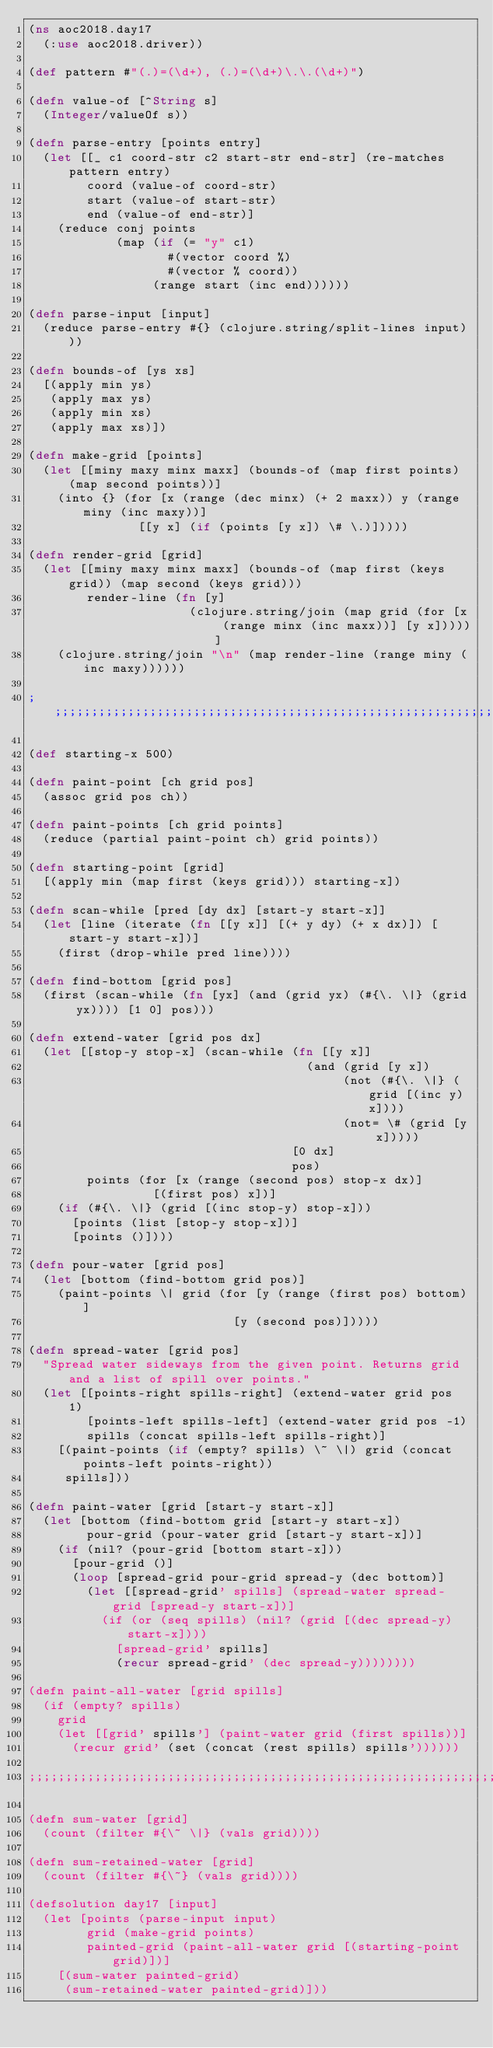Convert code to text. <code><loc_0><loc_0><loc_500><loc_500><_Clojure_>(ns aoc2018.day17
  (:use aoc2018.driver))

(def pattern #"(.)=(\d+), (.)=(\d+)\.\.(\d+)")

(defn value-of [^String s]
  (Integer/valueOf s))

(defn parse-entry [points entry]
  (let [[_ c1 coord-str c2 start-str end-str] (re-matches pattern entry)
        coord (value-of coord-str)
        start (value-of start-str)
        end (value-of end-str)]
    (reduce conj points
            (map (if (= "y" c1)
                   #(vector coord %)
                   #(vector % coord))
                 (range start (inc end))))))

(defn parse-input [input]
  (reduce parse-entry #{} (clojure.string/split-lines input)))

(defn bounds-of [ys xs]
  [(apply min ys)
   (apply max ys)
   (apply min xs)
   (apply max xs)])

(defn make-grid [points]
  (let [[miny maxy minx maxx] (bounds-of (map first points) (map second points))]
    (into {} (for [x (range (dec minx) (+ 2 maxx)) y (range miny (inc maxy))]
               [[y x] (if (points [y x]) \# \.)]))))

(defn render-grid [grid]
  (let [[miny maxy minx maxx] (bounds-of (map first (keys grid)) (map second (keys grid)))
        render-line (fn [y]
                      (clojure.string/join (map grid (for [x (range minx (inc maxx))] [y x]))))]
    (clojure.string/join "\n" (map render-line (range miny (inc maxy))))))

;;;;;;;;;;;;;;;;;;;;;;;;;;;;;;;;;;;;;;;;;;;;;;;;;;;;;;;;;;;;;;;;

(def starting-x 500)

(defn paint-point [ch grid pos]
  (assoc grid pos ch))

(defn paint-points [ch grid points]
  (reduce (partial paint-point ch) grid points))

(defn starting-point [grid]
  [(apply min (map first (keys grid))) starting-x])

(defn scan-while [pred [dy dx] [start-y start-x]]
  (let [line (iterate (fn [[y x]] [(+ y dy) (+ x dx)]) [start-y start-x])]
    (first (drop-while pred line))))

(defn find-bottom [grid pos]
  (first (scan-while (fn [yx] (and (grid yx) (#{\. \|} (grid yx)))) [1 0] pos)))

(defn extend-water [grid pos dx]
  (let [[stop-y stop-x] (scan-while (fn [[y x]]
                                      (and (grid [y x])
                                           (not (#{\. \|} (grid [(inc y) x])))
                                           (not= \# (grid [y x]))))
                                    [0 dx]
                                    pos)
        points (for [x (range (second pos) stop-x dx)]
                 [(first pos) x])]
    (if (#{\. \|} (grid [(inc stop-y) stop-x]))
      [points (list [stop-y stop-x])]
      [points ()])))

(defn pour-water [grid pos]
  (let [bottom (find-bottom grid pos)]
    (paint-points \| grid (for [y (range (first pos) bottom)]
                            [y (second pos)]))))

(defn spread-water [grid pos]
  "Spread water sideways from the given point. Returns grid and a list of spill over points."
  (let [[points-right spills-right] (extend-water grid pos 1)
        [points-left spills-left] (extend-water grid pos -1)
        spills (concat spills-left spills-right)]
    [(paint-points (if (empty? spills) \~ \|) grid (concat points-left points-right))
     spills]))

(defn paint-water [grid [start-y start-x]]
  (let [bottom (find-bottom grid [start-y start-x])
        pour-grid (pour-water grid [start-y start-x])]
    (if (nil? (pour-grid [bottom start-x]))
      [pour-grid ()]
      (loop [spread-grid pour-grid spread-y (dec bottom)]
        (let [[spread-grid' spills] (spread-water spread-grid [spread-y start-x])]
          (if (or (seq spills) (nil? (grid [(dec spread-y) start-x])))
            [spread-grid' spills]
            (recur spread-grid' (dec spread-y))))))))

(defn paint-all-water [grid spills]
  (if (empty? spills)
    grid
    (let [[grid' spills'] (paint-water grid (first spills))]
      (recur grid' (set (concat (rest spills) spills'))))))

;;;;;;;;;;;;;;;;;;;;;;;;;;;;;;;;;;;;;;;;;;;;;;;;;;;;;;;;;;;;;;;;

(defn sum-water [grid]
  (count (filter #{\~ \|} (vals grid))))

(defn sum-retained-water [grid]
  (count (filter #{\~} (vals grid))))

(defsolution day17 [input]
  (let [points (parse-input input)
        grid (make-grid points)
        painted-grid (paint-all-water grid [(starting-point grid)])]
    [(sum-water painted-grid)
     (sum-retained-water painted-grid)]))
</code> 